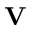<formula> <loc_0><loc_0><loc_500><loc_500>V</formula> 